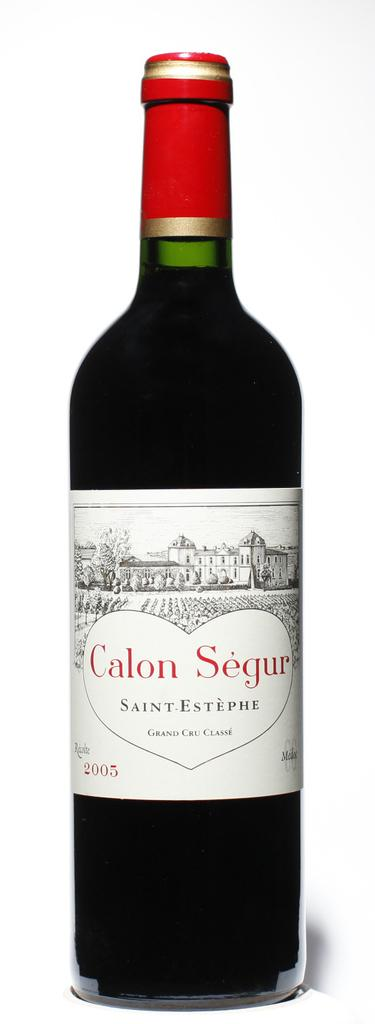<image>
Share a concise interpretation of the image provided. The bottle of Saint-Estephe Calon Segur Grand Cru Classe is dated 2005. 